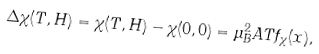Convert formula to latex. <formula><loc_0><loc_0><loc_500><loc_500>\Delta \chi ( T , H ) = \chi ( T , H ) - \chi ( 0 , 0 ) = \mu _ { B } ^ { 2 } A T f _ { \chi } ( x ) ,</formula> 